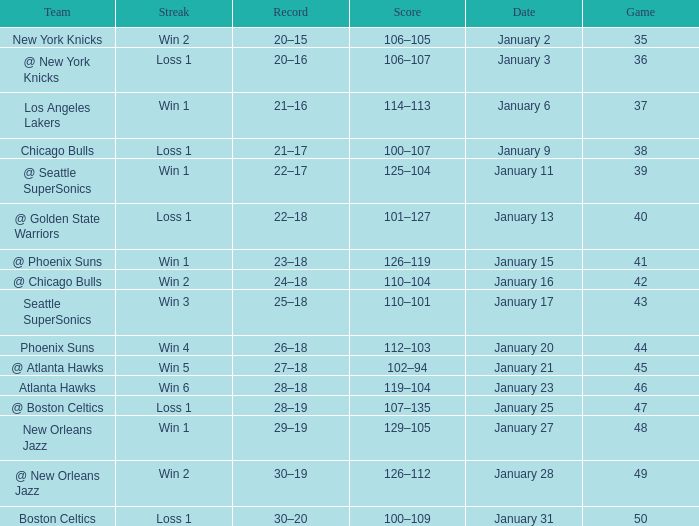What Game had a Score of 129–105? 48.0. 